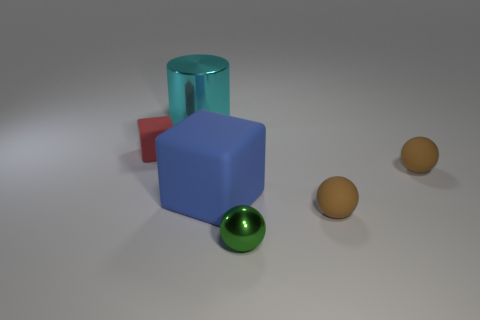Subtract all green metal balls. How many balls are left? 2 Add 3 green objects. How many objects exist? 9 Subtract all blue cubes. How many cubes are left? 1 Subtract all cylinders. How many objects are left? 5 Subtract all brown cylinders. How many brown balls are left? 2 Add 2 blue rubber things. How many blue rubber things exist? 3 Subtract 1 cyan cylinders. How many objects are left? 5 Subtract 2 balls. How many balls are left? 1 Subtract all green spheres. Subtract all brown cubes. How many spheres are left? 2 Subtract all tiny yellow rubber spheres. Subtract all large blue rubber cubes. How many objects are left? 5 